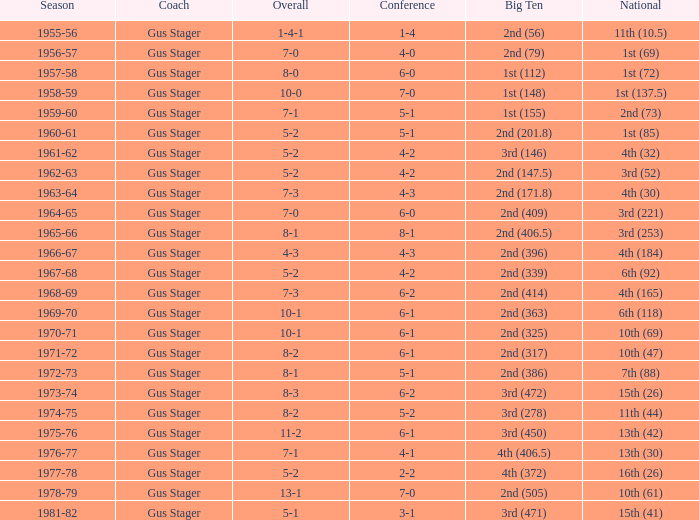Write the full table. {'header': ['Season', 'Coach', 'Overall', 'Conference', 'Big Ten', 'National'], 'rows': [['1955-56', 'Gus Stager', '1-4-1', '1-4', '2nd (56)', '11th (10.5)'], ['1956-57', 'Gus Stager', '7-0', '4-0', '2nd (79)', '1st (69)'], ['1957-58', 'Gus Stager', '8-0', '6-0', '1st (112)', '1st (72)'], ['1958-59', 'Gus Stager', '10-0', '7-0', '1st (148)', '1st (137.5)'], ['1959-60', 'Gus Stager', '7-1', '5-1', '1st (155)', '2nd (73)'], ['1960-61', 'Gus Stager', '5-2', '5-1', '2nd (201.8)', '1st (85)'], ['1961-62', 'Gus Stager', '5-2', '4-2', '3rd (146)', '4th (32)'], ['1962-63', 'Gus Stager', '5-2', '4-2', '2nd (147.5)', '3rd (52)'], ['1963-64', 'Gus Stager', '7-3', '4-3', '2nd (171.8)', '4th (30)'], ['1964-65', 'Gus Stager', '7-0', '6-0', '2nd (409)', '3rd (221)'], ['1965-66', 'Gus Stager', '8-1', '8-1', '2nd (406.5)', '3rd (253)'], ['1966-67', 'Gus Stager', '4-3', '4-3', '2nd (396)', '4th (184)'], ['1967-68', 'Gus Stager', '5-2', '4-2', '2nd (339)', '6th (92)'], ['1968-69', 'Gus Stager', '7-3', '6-2', '2nd (414)', '4th (165)'], ['1969-70', 'Gus Stager', '10-1', '6-1', '2nd (363)', '6th (118)'], ['1970-71', 'Gus Stager', '10-1', '6-1', '2nd (325)', '10th (69)'], ['1971-72', 'Gus Stager', '8-2', '6-1', '2nd (317)', '10th (47)'], ['1972-73', 'Gus Stager', '8-1', '5-1', '2nd (386)', '7th (88)'], ['1973-74', 'Gus Stager', '8-3', '6-2', '3rd (472)', '15th (26)'], ['1974-75', 'Gus Stager', '8-2', '5-2', '3rd (278)', '11th (44)'], ['1975-76', 'Gus Stager', '11-2', '6-1', '3rd (450)', '13th (42)'], ['1976-77', 'Gus Stager', '7-1', '4-1', '4th (406.5)', '13th (30)'], ['1977-78', 'Gus Stager', '5-2', '2-2', '4th (372)', '16th (26)'], ['1978-79', 'Gus Stager', '13-1', '7-0', '2nd (505)', '10th (61)'], ['1981-82', 'Gus Stager', '5-1', '3-1', '3rd (471)', '15th (41)']]} What is the Coach with a Big Ten that is 1st (148)? Gus Stager. 